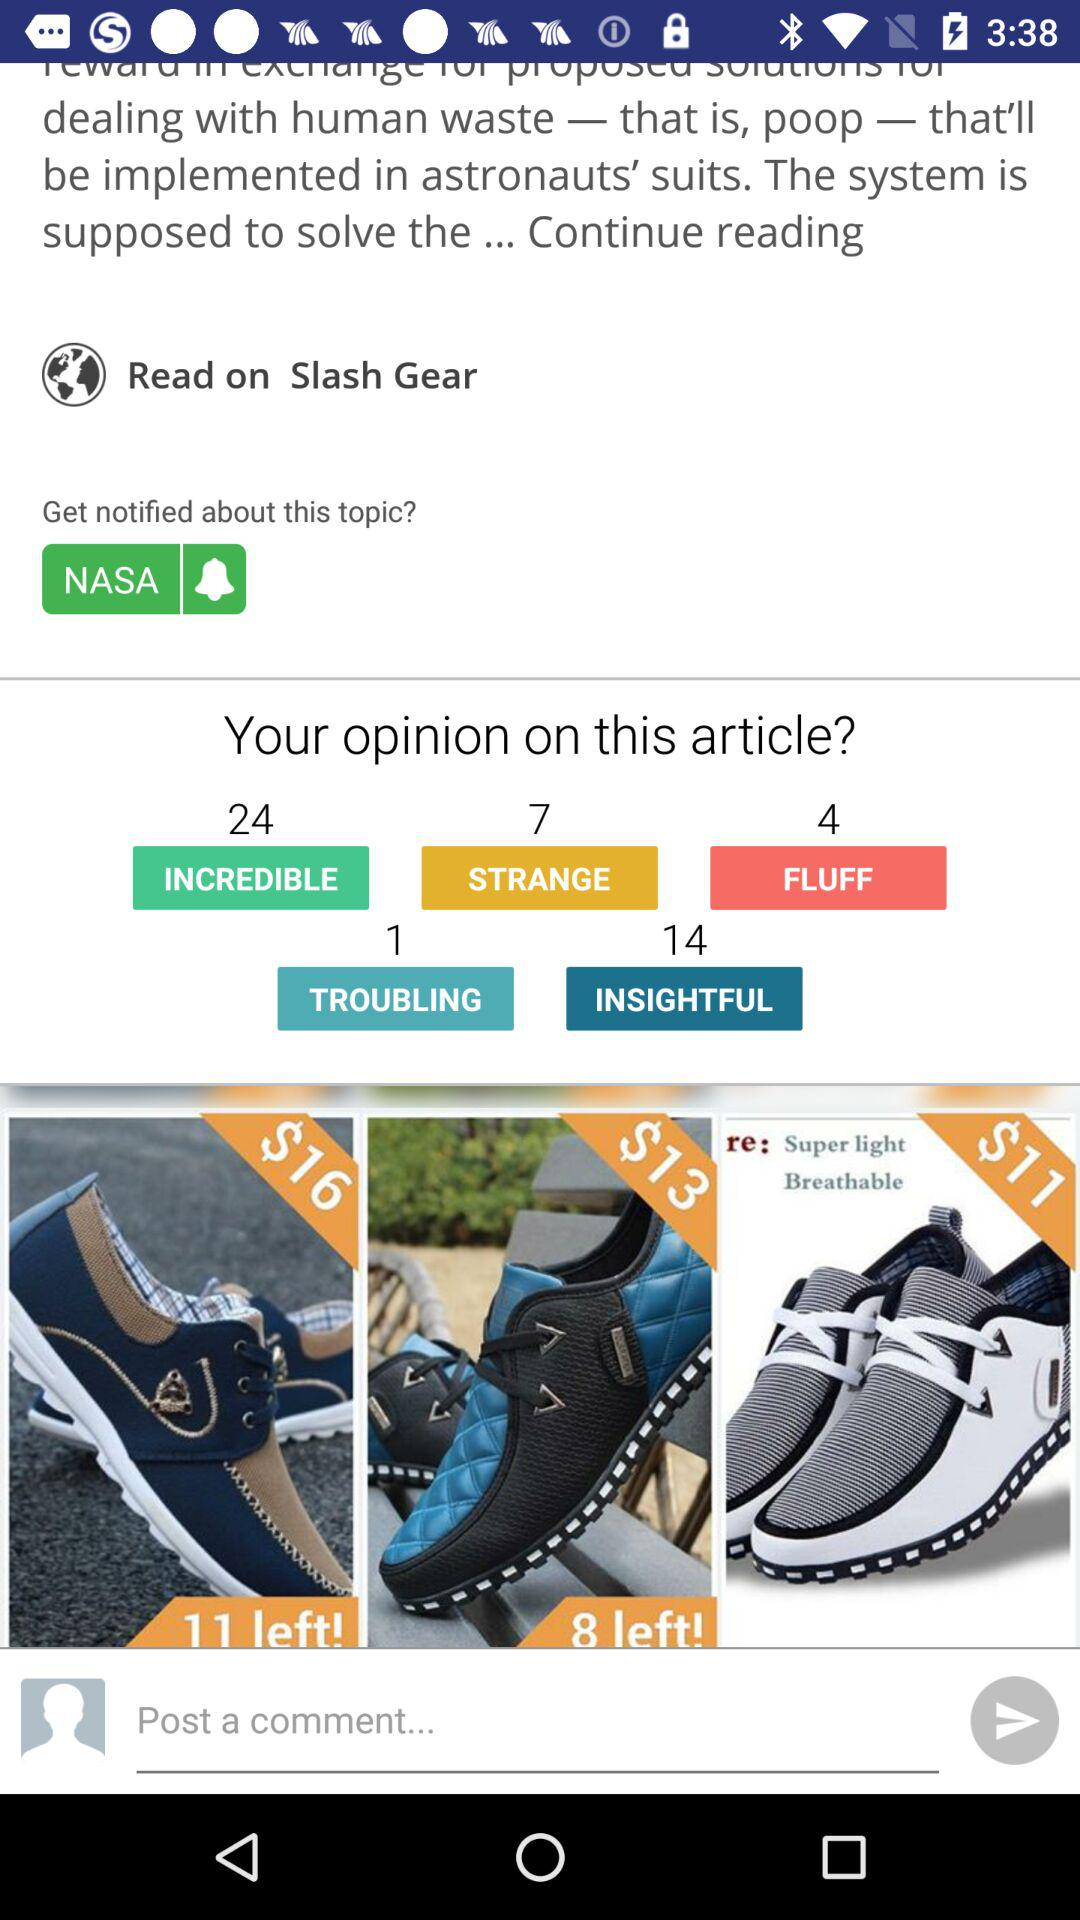Where can I read the article? You can read the article on slash gear. 